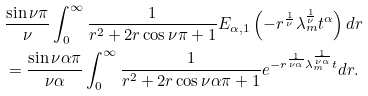<formula> <loc_0><loc_0><loc_500><loc_500>& \frac { \sin \nu \pi } { \nu } \int _ { 0 } ^ { \infty } \frac { 1 } { r ^ { 2 } + 2 r \cos \nu \pi + 1 } E _ { \alpha , 1 } \left ( - r ^ { \frac { 1 } { \nu } } \lambda _ { m } ^ { \frac { 1 } { \nu } } t ^ { \alpha } \right ) d r \\ & = \frac { \sin \nu \alpha \pi } { \nu \alpha } \int _ { 0 } ^ { \infty } \frac { 1 } { r ^ { 2 } + 2 r \cos \nu \alpha \pi + 1 } e ^ { - r ^ { \frac { 1 } { \nu \alpha } } \lambda _ { m } ^ { \frac { 1 } { \nu \alpha } } t } d r .</formula> 